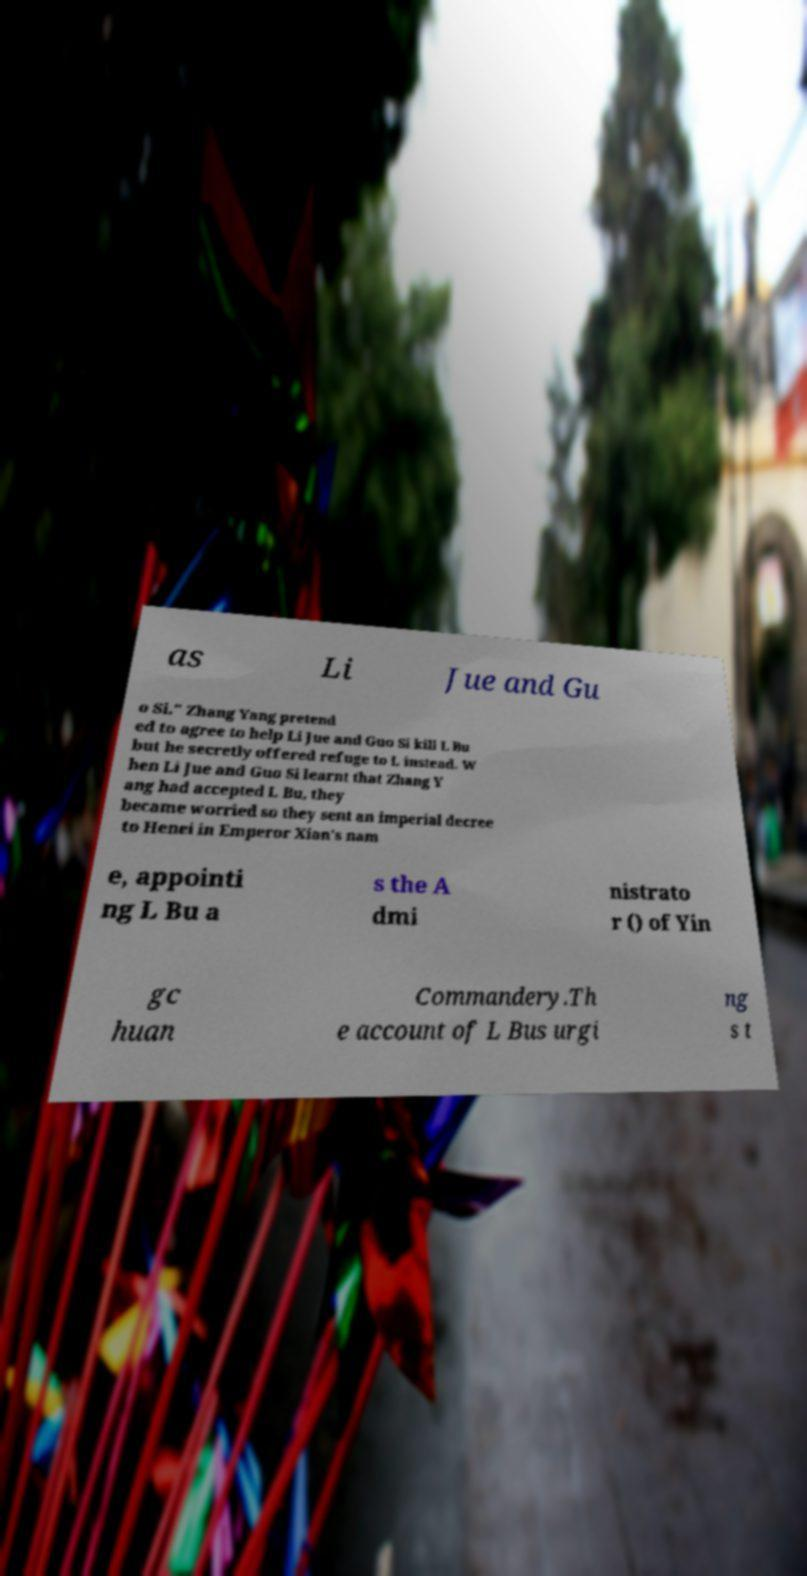Can you read and provide the text displayed in the image?This photo seems to have some interesting text. Can you extract and type it out for me? as Li Jue and Gu o Si." Zhang Yang pretend ed to agree to help Li Jue and Guo Si kill L Bu but he secretly offered refuge to L instead. W hen Li Jue and Guo Si learnt that Zhang Y ang had accepted L Bu, they became worried so they sent an imperial decree to Henei in Emperor Xian's nam e, appointi ng L Bu a s the A dmi nistrato r () of Yin gc huan Commandery.Th e account of L Bus urgi ng s t 